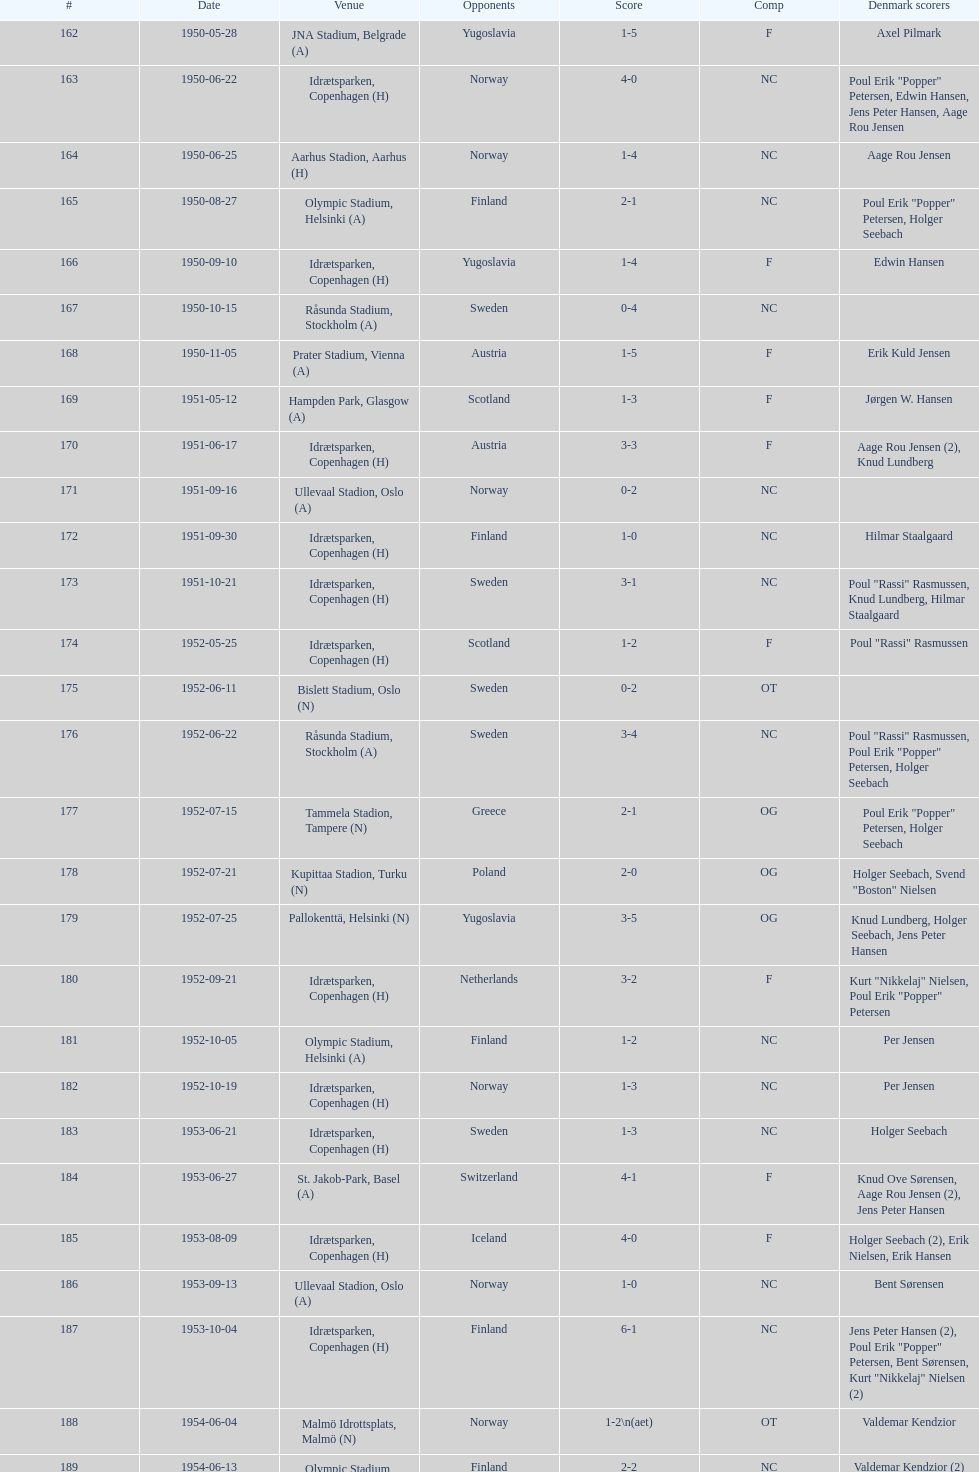Which venue is situated right under jna stadium, belgrade (a)? Idrætsparken, Copenhagen (H). 